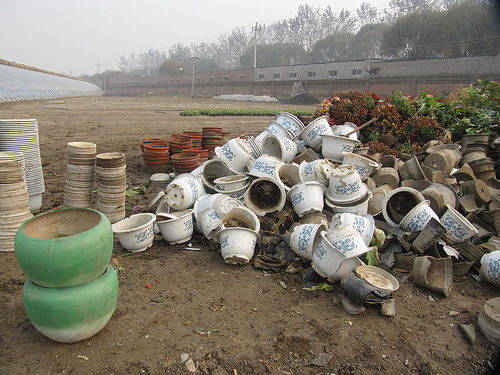<image>
Is the pot on the ground? Yes. Looking at the image, I can see the pot is positioned on top of the ground, with the ground providing support. 